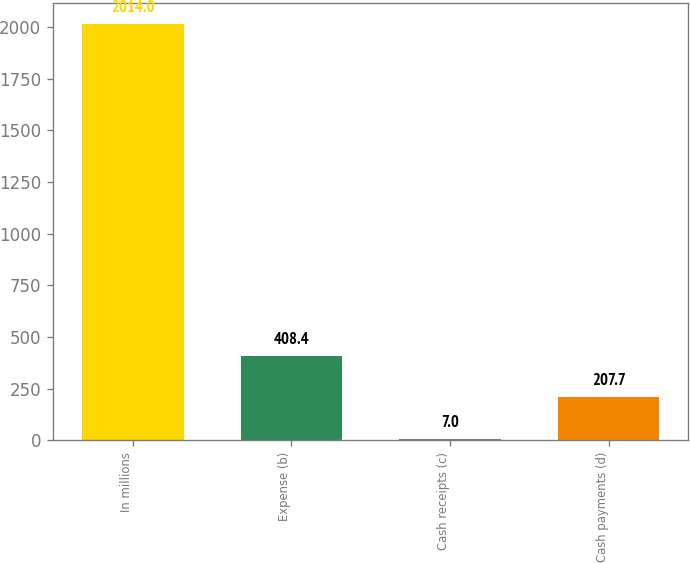Convert chart to OTSL. <chart><loc_0><loc_0><loc_500><loc_500><bar_chart><fcel>In millions<fcel>Expense (b)<fcel>Cash receipts (c)<fcel>Cash payments (d)<nl><fcel>2014<fcel>408.4<fcel>7<fcel>207.7<nl></chart> 